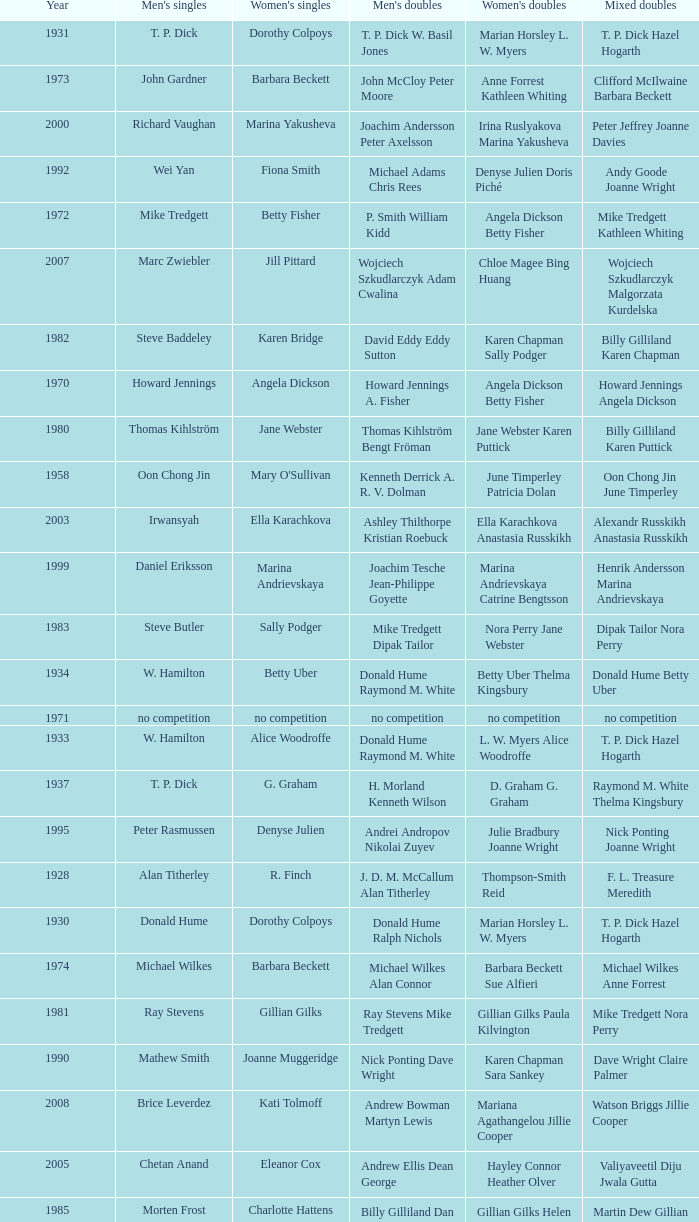Who won the Women's doubles in the year that Jesper Knudsen Nettie Nielsen won the Mixed doubles? Karen Beckman Sara Halsall. 